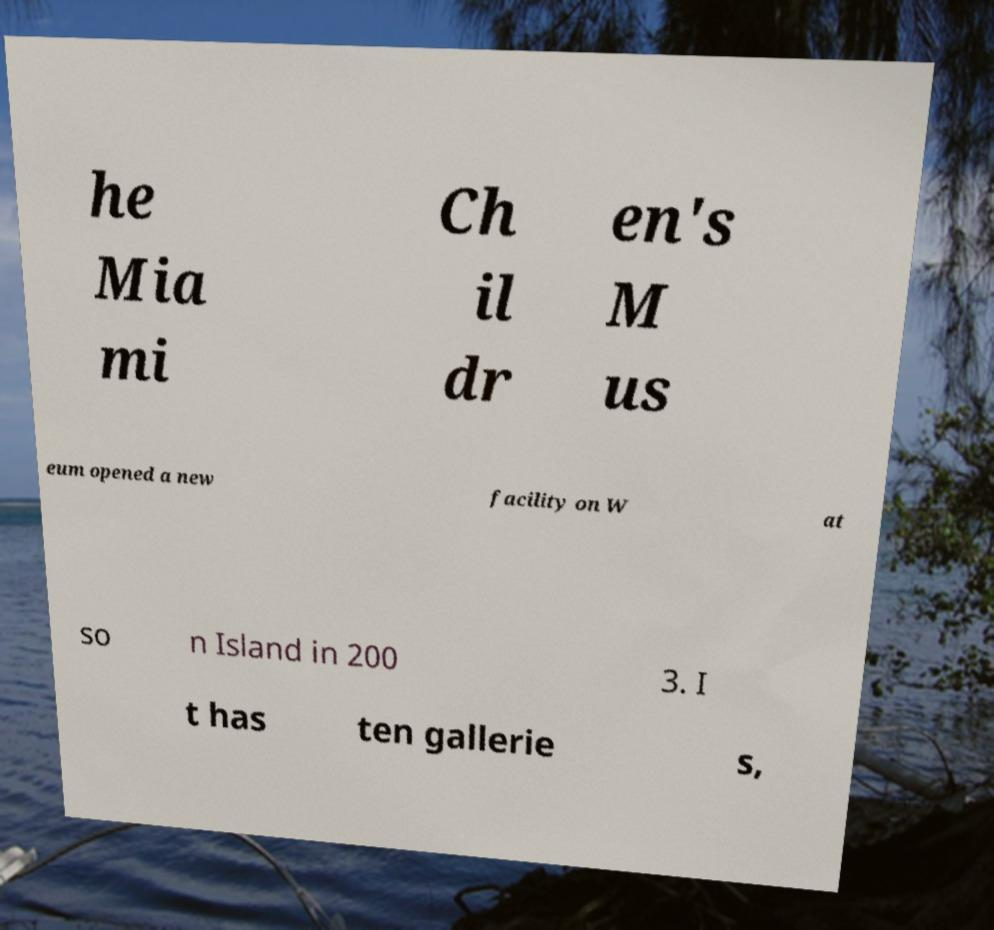Can you read and provide the text displayed in the image?This photo seems to have some interesting text. Can you extract and type it out for me? he Mia mi Ch il dr en's M us eum opened a new facility on W at so n Island in 200 3. I t has ten gallerie s, 